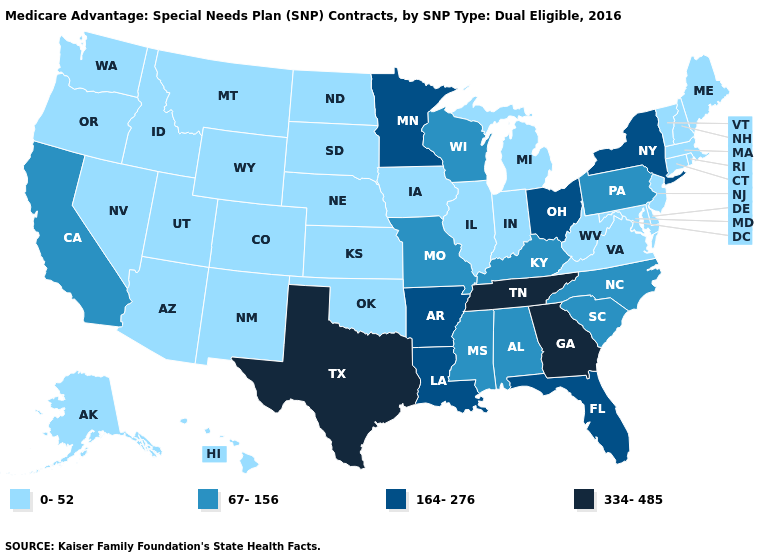What is the value of Alaska?
Keep it brief. 0-52. What is the highest value in states that border South Carolina?
Be succinct. 334-485. Name the states that have a value in the range 334-485?
Keep it brief. Georgia, Tennessee, Texas. What is the value of Connecticut?
Answer briefly. 0-52. Which states have the highest value in the USA?
Answer briefly. Georgia, Tennessee, Texas. Among the states that border Vermont , does New Hampshire have the highest value?
Be succinct. No. Which states have the highest value in the USA?
Answer briefly. Georgia, Tennessee, Texas. What is the lowest value in the USA?
Give a very brief answer. 0-52. Which states have the lowest value in the Northeast?
Quick response, please. Connecticut, Massachusetts, Maine, New Hampshire, New Jersey, Rhode Island, Vermont. Does North Dakota have a higher value than Washington?
Quick response, please. No. Which states hav the highest value in the MidWest?
Quick response, please. Minnesota, Ohio. What is the lowest value in the USA?
Quick response, please. 0-52. Does the map have missing data?
Short answer required. No. What is the lowest value in the USA?
Write a very short answer. 0-52. Among the states that border Kansas , does Nebraska have the highest value?
Be succinct. No. 